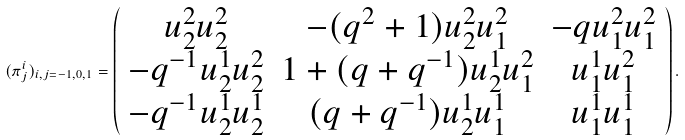Convert formula to latex. <formula><loc_0><loc_0><loc_500><loc_500>( \pi ^ { i } _ { j } ) _ { i , j = - 1 , 0 , 1 } = \left ( \begin{array} { c c c } u ^ { 2 } _ { 2 } u ^ { 2 } _ { 2 } & - ( q ^ { 2 } + 1 ) u ^ { 2 } _ { 2 } u ^ { 2 } _ { 1 } & - q u ^ { 2 } _ { 1 } u ^ { 2 } _ { 1 } \\ - q ^ { - 1 } u ^ { 1 } _ { 2 } u ^ { 2 } _ { 2 } & 1 + ( q + q ^ { - 1 } ) u ^ { 1 } _ { 2 } u ^ { 2 } _ { 1 } & u ^ { 1 } _ { 1 } u ^ { 2 } _ { 1 } \\ - q ^ { - 1 } u ^ { 1 } _ { 2 } u ^ { 1 } _ { 2 } & ( q + q ^ { - 1 } ) u ^ { 1 } _ { 2 } u ^ { 1 } _ { 1 } & u ^ { 1 } _ { 1 } u ^ { 1 } _ { 1 } \end{array} \right ) .</formula> 